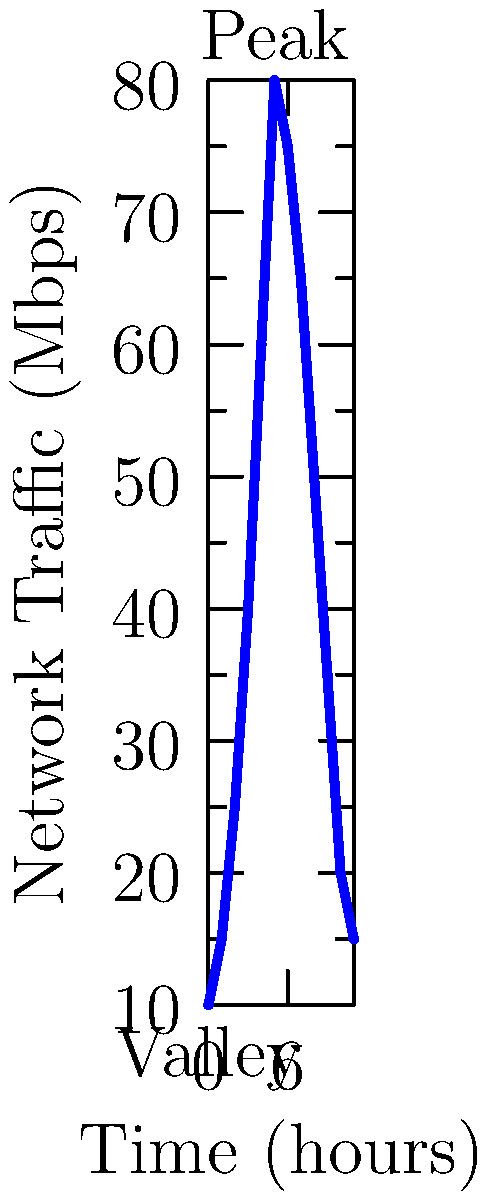Given the time series chart of network traffic patterns, what technique would you employ to detect anomalies that could indicate potential DDoS attacks or system failures, considering the cyclical nature of the traffic? To detect anomalies in this cyclical network traffic pattern, we should follow these steps:

1. Establish a baseline: Analyze the regular pattern shown in the graph. The traffic follows a clear cycle, peaking around hour 5 and reaching its lowest point at hour 0.

2. Calculate moving averages: Implement a moving average calculation to smooth out short-term fluctuations and highlight longer-term trends.

3. Set threshold limits: Define upper and lower threshold limits based on historical data, typically using standard deviations from the moving average.

4. Implement time series decomposition: Break down the time series into its components:
   a) Trend: Long-term increase or decrease in the data
   b) Seasonality: Repeating patterns or cycles in the data
   c) Residual: The remaining variation after removing trend and seasonality

5. Apply statistical methods: Use techniques like ARIMA (AutoRegressive Integrated Moving Average) or exponential smoothing to forecast expected values.

6. Monitor in real-time: Continuously compare incoming data points against the forecasted values and established thresholds.

7. Trigger alerts: Set up a system to flag any data points that significantly deviate from the expected values, potentially indicating a DDoS attack or system failure.

8. Incorporate machine learning: Implement algorithms like isolation forests or autoencoders to improve anomaly detection over time.

9. Consider context: Factor in known events or maintenance windows that might affect traffic patterns to reduce false positives.

The most effective technique would be a combination of time series decomposition and machine learning algorithms, as they can adapt to the cyclical nature of the traffic while still detecting unusual deviations.
Answer: Time series decomposition combined with adaptive machine learning algorithms 